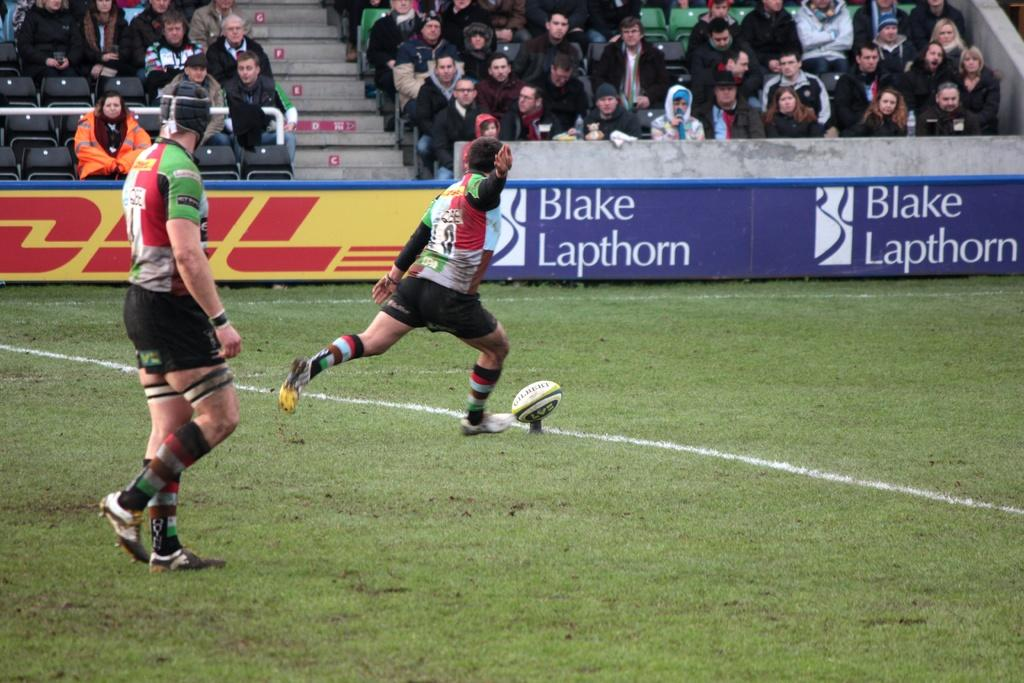<image>
Summarize the visual content of the image. A rugby player is about to kick the ball as people watch from behind the Blake Lapthorn sign on the bleachers. 